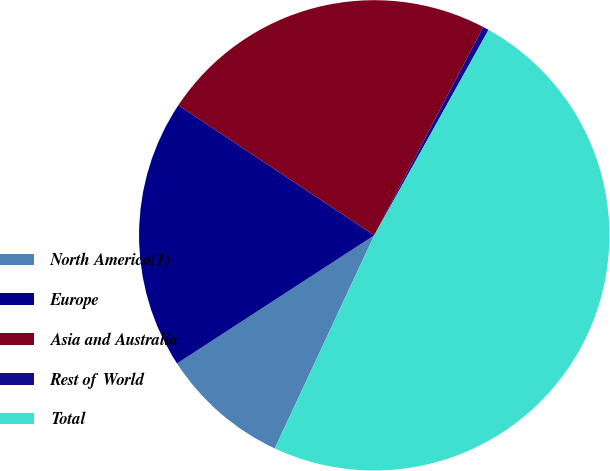Convert chart to OTSL. <chart><loc_0><loc_0><loc_500><loc_500><pie_chart><fcel>North America(1)<fcel>Europe<fcel>Asia and Australia<fcel>Rest of World<fcel>Total<nl><fcel>8.88%<fcel>18.5%<fcel>23.34%<fcel>0.41%<fcel>48.87%<nl></chart> 